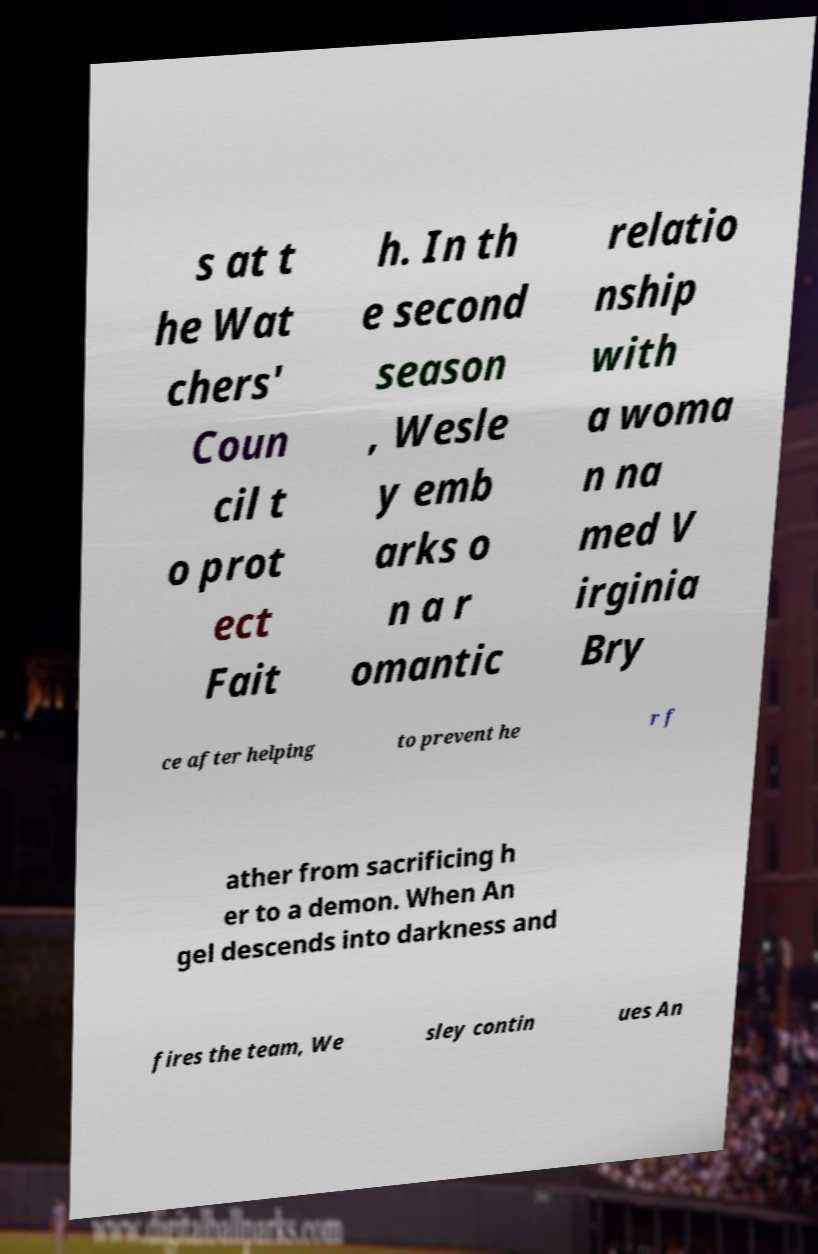For documentation purposes, I need the text within this image transcribed. Could you provide that? s at t he Wat chers' Coun cil t o prot ect Fait h. In th e second season , Wesle y emb arks o n a r omantic relatio nship with a woma n na med V irginia Bry ce after helping to prevent he r f ather from sacrificing h er to a demon. When An gel descends into darkness and fires the team, We sley contin ues An 